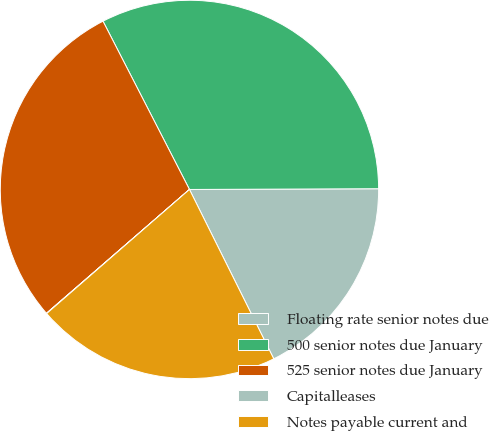Convert chart to OTSL. <chart><loc_0><loc_0><loc_500><loc_500><pie_chart><fcel>Floating rate senior notes due<fcel>500 senior notes due January<fcel>525 senior notes due January<fcel>Capitalleases<fcel>Notes payable current and<nl><fcel>17.71%<fcel>32.49%<fcel>28.8%<fcel>0.03%<fcel>20.96%<nl></chart> 